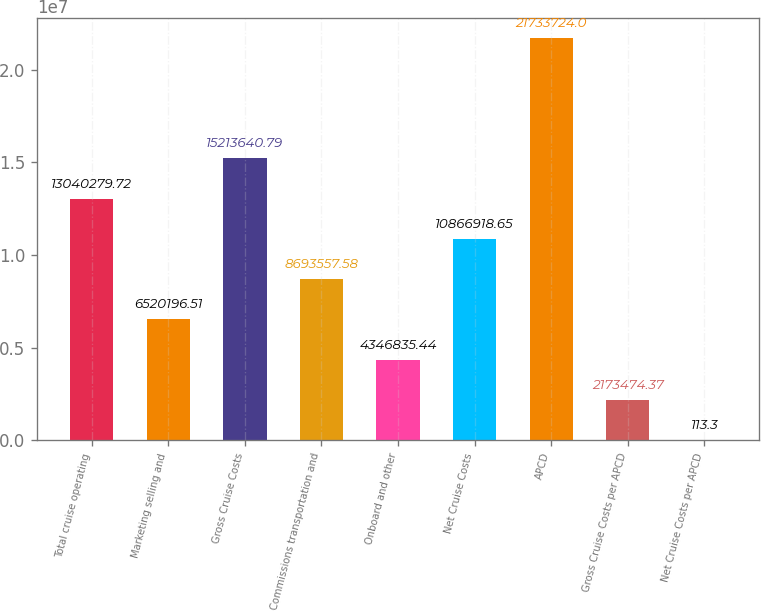Convert chart. <chart><loc_0><loc_0><loc_500><loc_500><bar_chart><fcel>Total cruise operating<fcel>Marketing selling and<fcel>Gross Cruise Costs<fcel>Commissions transportation and<fcel>Onboard and other<fcel>Net Cruise Costs<fcel>APCD<fcel>Gross Cruise Costs per APCD<fcel>Net Cruise Costs per APCD<nl><fcel>1.30403e+07<fcel>6.5202e+06<fcel>1.52136e+07<fcel>8.69356e+06<fcel>4.34684e+06<fcel>1.08669e+07<fcel>2.17337e+07<fcel>2.17347e+06<fcel>113.3<nl></chart> 